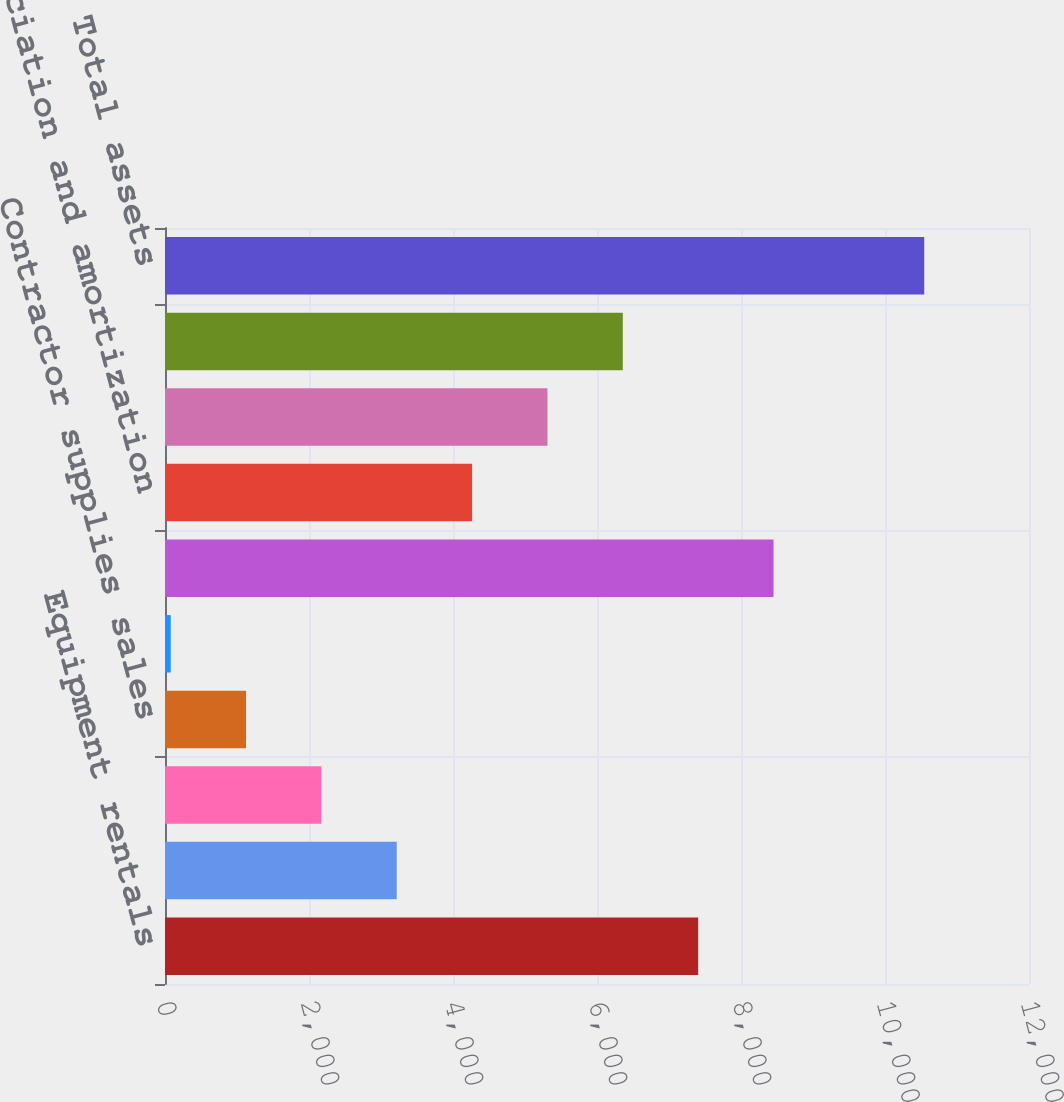Convert chart to OTSL. <chart><loc_0><loc_0><loc_500><loc_500><bar_chart><fcel>Equipment rentals<fcel>Sales of rental equipment<fcel>Sales of new equipment<fcel>Contractor supplies sales<fcel>Service and other revenues<fcel>Total revenue<fcel>Depreciation and amortization<fcel>Equipment rentals gross profit<fcel>Capital expenditures<fcel>Total assets<nl><fcel>7405.2<fcel>3218.8<fcel>2172.2<fcel>1125.6<fcel>79<fcel>8451.8<fcel>4265.4<fcel>5312<fcel>6358.6<fcel>10545<nl></chart> 